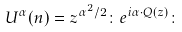<formula> <loc_0><loc_0><loc_500><loc_500>U ^ { \alpha } ( n ) = z ^ { { \alpha } ^ { 2 } / 2 } \colon e ^ { i \alpha \cdot Q ( z ) } \colon</formula> 